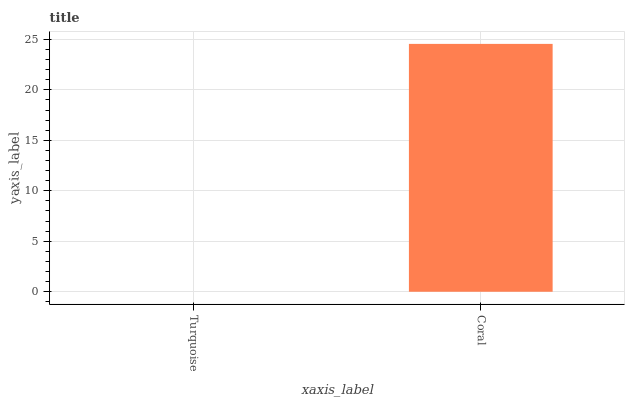Is Turquoise the minimum?
Answer yes or no. Yes. Is Coral the maximum?
Answer yes or no. Yes. Is Coral the minimum?
Answer yes or no. No. Is Coral greater than Turquoise?
Answer yes or no. Yes. Is Turquoise less than Coral?
Answer yes or no. Yes. Is Turquoise greater than Coral?
Answer yes or no. No. Is Coral less than Turquoise?
Answer yes or no. No. Is Coral the high median?
Answer yes or no. Yes. Is Turquoise the low median?
Answer yes or no. Yes. Is Turquoise the high median?
Answer yes or no. No. Is Coral the low median?
Answer yes or no. No. 